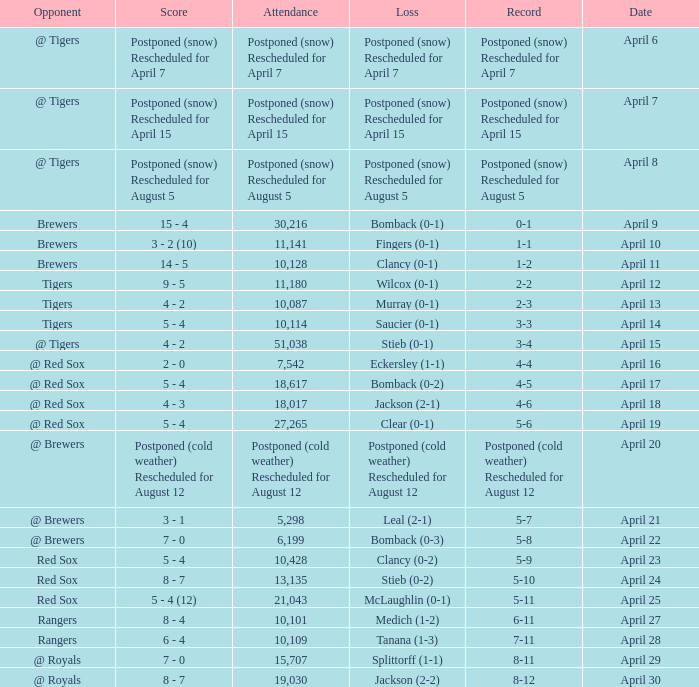What is the score for the game that has an attendance of 5,298? 3 - 1. Can you give me this table as a dict? {'header': ['Opponent', 'Score', 'Attendance', 'Loss', 'Record', 'Date'], 'rows': [['@ Tigers', 'Postponed (snow) Rescheduled for April 7', 'Postponed (snow) Rescheduled for April 7', 'Postponed (snow) Rescheduled for April 7', 'Postponed (snow) Rescheduled for April 7', 'April 6'], ['@ Tigers', 'Postponed (snow) Rescheduled for April 15', 'Postponed (snow) Rescheduled for April 15', 'Postponed (snow) Rescheduled for April 15', 'Postponed (snow) Rescheduled for April 15', 'April 7'], ['@ Tigers', 'Postponed (snow) Rescheduled for August 5', 'Postponed (snow) Rescheduled for August 5', 'Postponed (snow) Rescheduled for August 5', 'Postponed (snow) Rescheduled for August 5', 'April 8'], ['Brewers', '15 - 4', '30,216', 'Bomback (0-1)', '0-1', 'April 9'], ['Brewers', '3 - 2 (10)', '11,141', 'Fingers (0-1)', '1-1', 'April 10'], ['Brewers', '14 - 5', '10,128', 'Clancy (0-1)', '1-2', 'April 11'], ['Tigers', '9 - 5', '11,180', 'Wilcox (0-1)', '2-2', 'April 12'], ['Tigers', '4 - 2', '10,087', 'Murray (0-1)', '2-3', 'April 13'], ['Tigers', '5 - 4', '10,114', 'Saucier (0-1)', '3-3', 'April 14'], ['@ Tigers', '4 - 2', '51,038', 'Stieb (0-1)', '3-4', 'April 15'], ['@ Red Sox', '2 - 0', '7,542', 'Eckersley (1-1)', '4-4', 'April 16'], ['@ Red Sox', '5 - 4', '18,617', 'Bomback (0-2)', '4-5', 'April 17'], ['@ Red Sox', '4 - 3', '18,017', 'Jackson (2-1)', '4-6', 'April 18'], ['@ Red Sox', '5 - 4', '27,265', 'Clear (0-1)', '5-6', 'April 19'], ['@ Brewers', 'Postponed (cold weather) Rescheduled for August 12', 'Postponed (cold weather) Rescheduled for August 12', 'Postponed (cold weather) Rescheduled for August 12', 'Postponed (cold weather) Rescheduled for August 12', 'April 20'], ['@ Brewers', '3 - 1', '5,298', 'Leal (2-1)', '5-7', 'April 21'], ['@ Brewers', '7 - 0', '6,199', 'Bomback (0-3)', '5-8', 'April 22'], ['Red Sox', '5 - 4', '10,428', 'Clancy (0-2)', '5-9', 'April 23'], ['Red Sox', '8 - 7', '13,135', 'Stieb (0-2)', '5-10', 'April 24'], ['Red Sox', '5 - 4 (12)', '21,043', 'McLaughlin (0-1)', '5-11', 'April 25'], ['Rangers', '8 - 4', '10,101', 'Medich (1-2)', '6-11', 'April 27'], ['Rangers', '6 - 4', '10,109', 'Tanana (1-3)', '7-11', 'April 28'], ['@ Royals', '7 - 0', '15,707', 'Splittorff (1-1)', '8-11', 'April 29'], ['@ Royals', '8 - 7', '19,030', 'Jackson (2-2)', '8-12', 'April 30']]} 